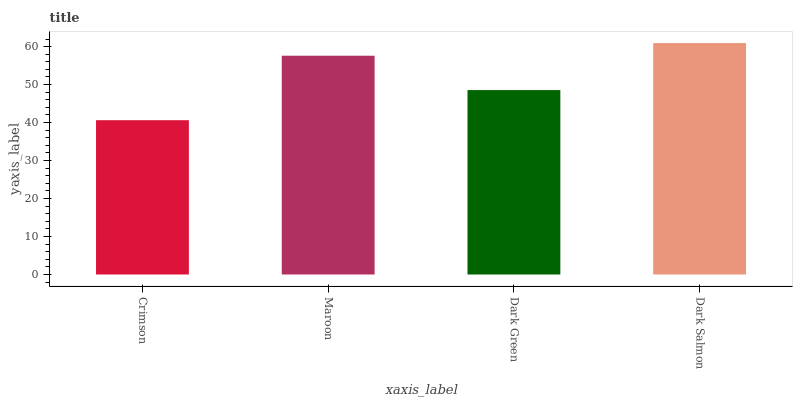Is Crimson the minimum?
Answer yes or no. Yes. Is Dark Salmon the maximum?
Answer yes or no. Yes. Is Maroon the minimum?
Answer yes or no. No. Is Maroon the maximum?
Answer yes or no. No. Is Maroon greater than Crimson?
Answer yes or no. Yes. Is Crimson less than Maroon?
Answer yes or no. Yes. Is Crimson greater than Maroon?
Answer yes or no. No. Is Maroon less than Crimson?
Answer yes or no. No. Is Maroon the high median?
Answer yes or no. Yes. Is Dark Green the low median?
Answer yes or no. Yes. Is Dark Green the high median?
Answer yes or no. No. Is Maroon the low median?
Answer yes or no. No. 